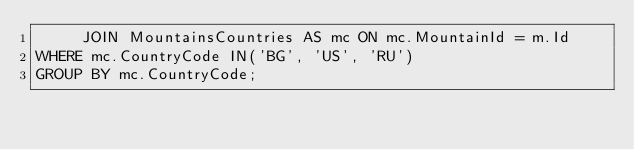Convert code to text. <code><loc_0><loc_0><loc_500><loc_500><_SQL_>     JOIN MountainsCountries AS mc ON mc.MountainId = m.Id
WHERE mc.CountryCode IN('BG', 'US', 'RU')
GROUP BY mc.CountryCode;</code> 